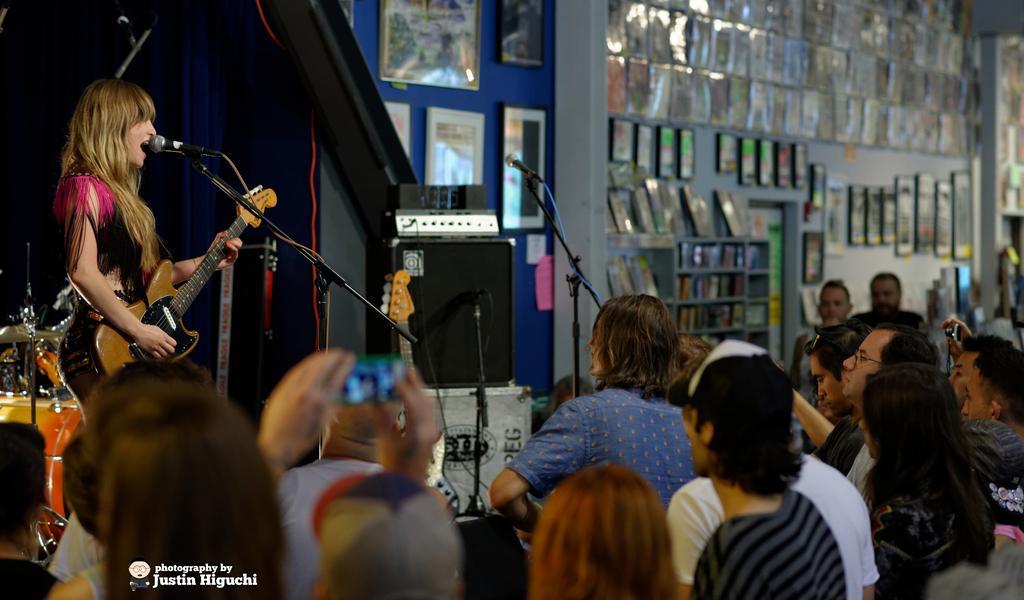How would you summarize this image in a sentence or two? In the image we can see there are lot of people who are sitting on chair and they are looking at a woman who is standing and holding guitar in her hand. 